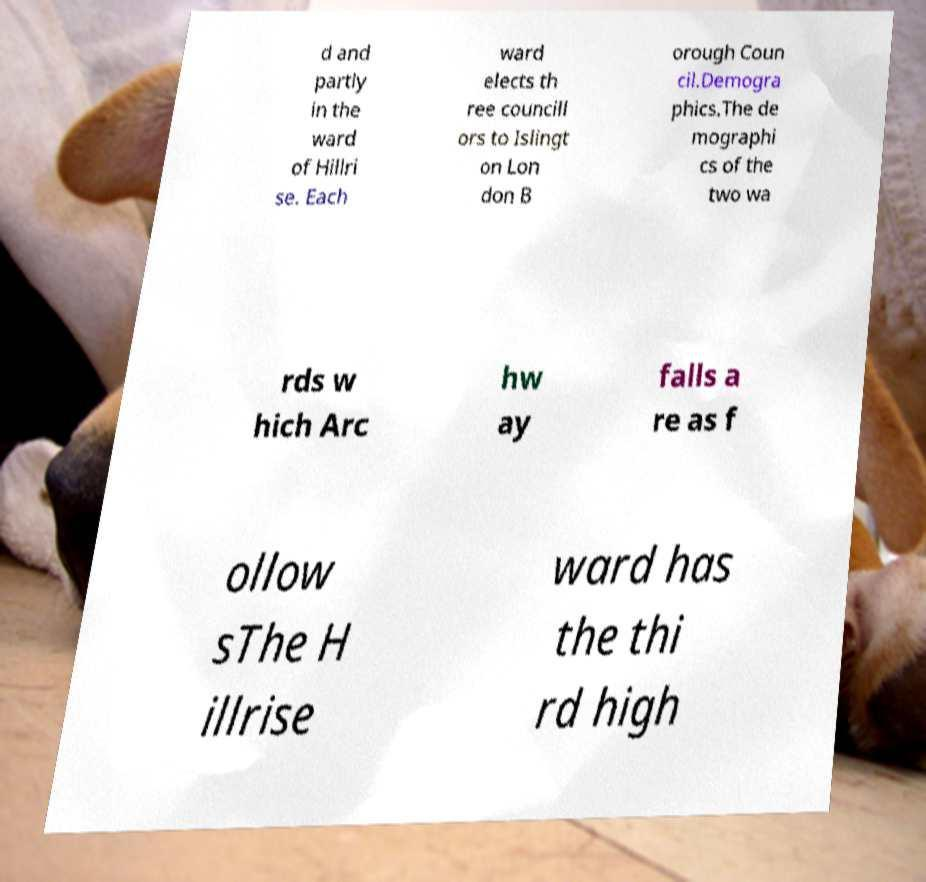For documentation purposes, I need the text within this image transcribed. Could you provide that? d and partly in the ward of Hillri se. Each ward elects th ree councill ors to Islingt on Lon don B orough Coun cil.Demogra phics.The de mographi cs of the two wa rds w hich Arc hw ay falls a re as f ollow sThe H illrise ward has the thi rd high 